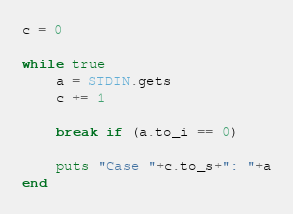Convert code to text. <code><loc_0><loc_0><loc_500><loc_500><_Ruby_>c = 0

while true
    a = STDIN.gets
    c += 1
 
    break if (a.to_i == 0)
 
    puts "Case "+c.to_s+": "+a
end
</code> 